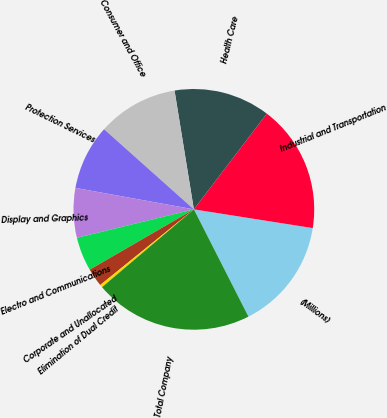Convert chart. <chart><loc_0><loc_0><loc_500><loc_500><pie_chart><fcel>(Millions)<fcel>Industrial and Transportation<fcel>Health Care<fcel>Consumer and Office<fcel>Protection Services<fcel>Display and Graphics<fcel>Electro and Communications<fcel>Corporate and Unallocated<fcel>Elimination of Dual Credit<fcel>Total Company<nl><fcel>15.02%<fcel>17.12%<fcel>12.93%<fcel>10.84%<fcel>8.74%<fcel>6.65%<fcel>4.56%<fcel>2.46%<fcel>0.37%<fcel>21.3%<nl></chart> 